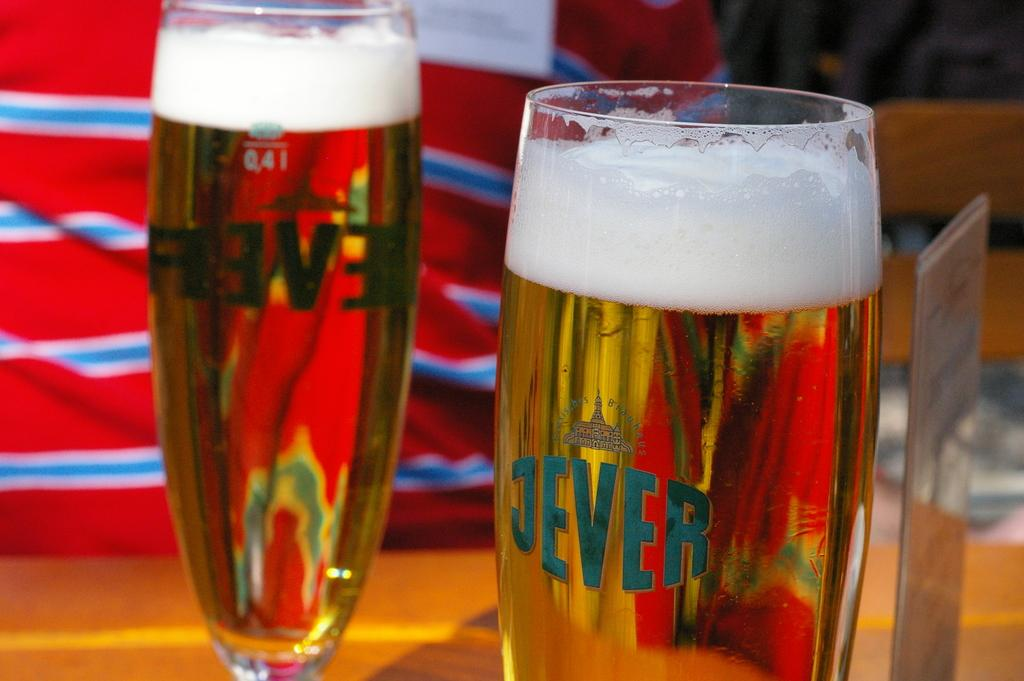<image>
Summarize the visual content of the image. Glasses with the logo "Jever" are filled with ale. 